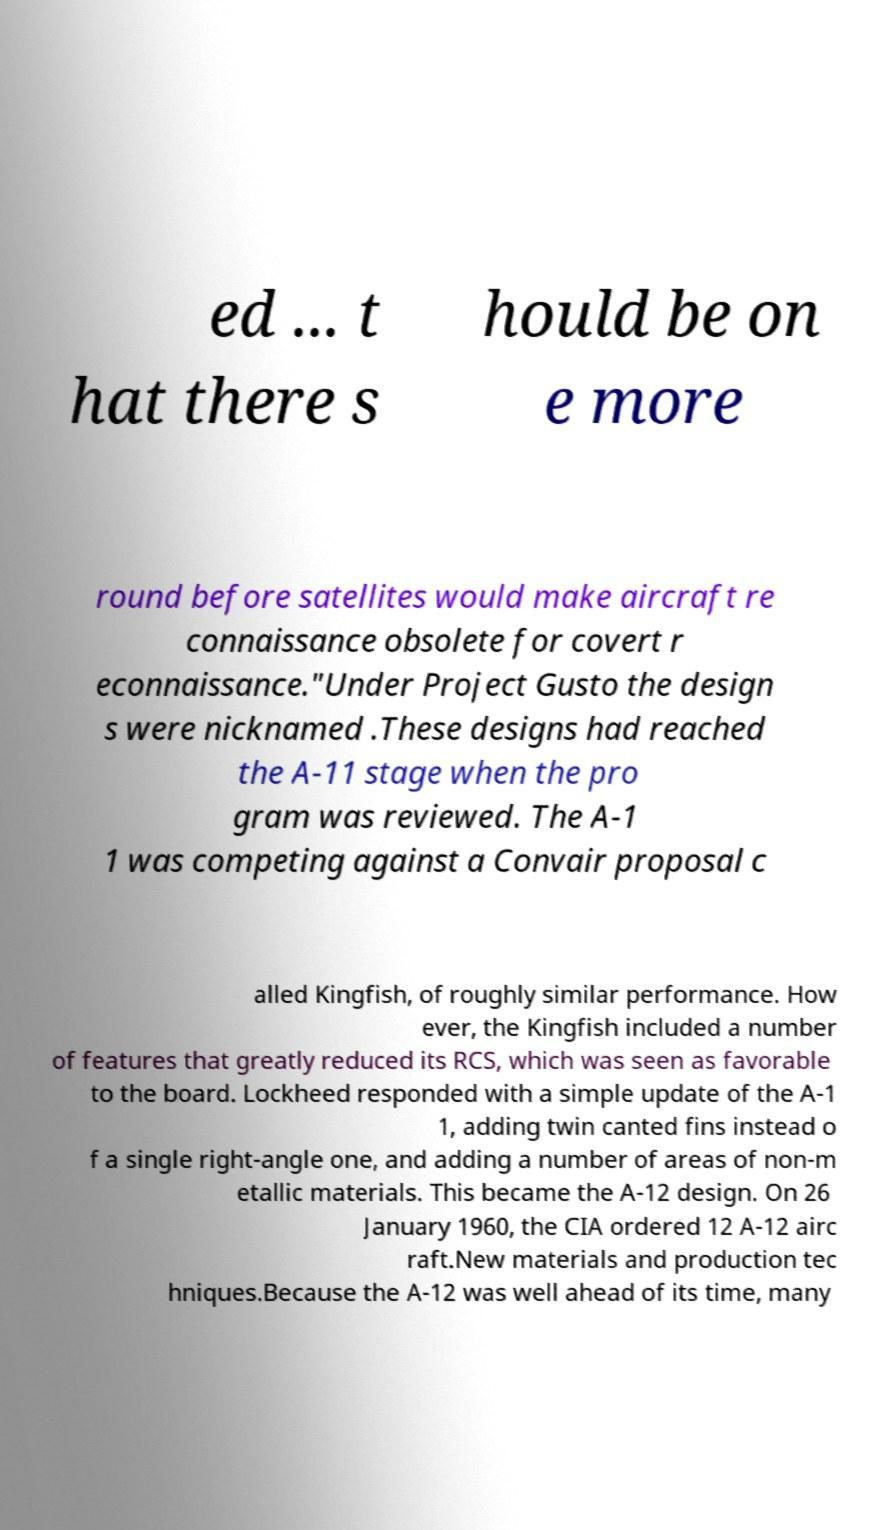Can you read and provide the text displayed in the image?This photo seems to have some interesting text. Can you extract and type it out for me? ed ... t hat there s hould be on e more round before satellites would make aircraft re connaissance obsolete for covert r econnaissance."Under Project Gusto the design s were nicknamed .These designs had reached the A-11 stage when the pro gram was reviewed. The A-1 1 was competing against a Convair proposal c alled Kingfish, of roughly similar performance. How ever, the Kingfish included a number of features that greatly reduced its RCS, which was seen as favorable to the board. Lockheed responded with a simple update of the A-1 1, adding twin canted fins instead o f a single right-angle one, and adding a number of areas of non-m etallic materials. This became the A-12 design. On 26 January 1960, the CIA ordered 12 A-12 airc raft.New materials and production tec hniques.Because the A-12 was well ahead of its time, many 